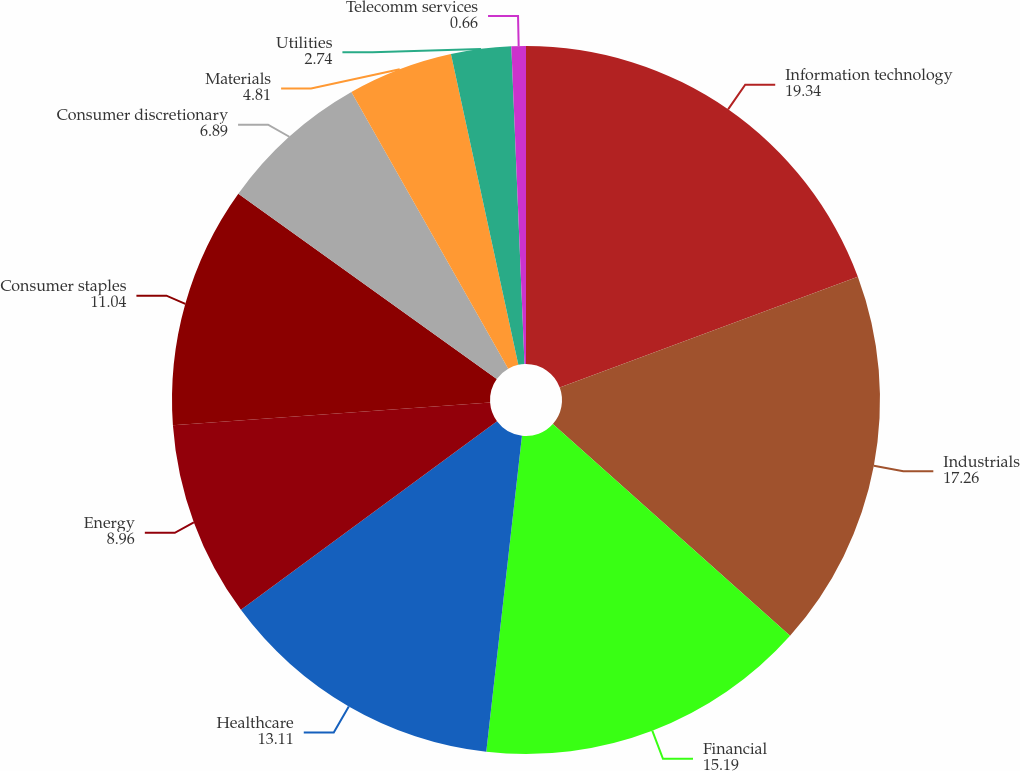Convert chart to OTSL. <chart><loc_0><loc_0><loc_500><loc_500><pie_chart><fcel>Information technology<fcel>Industrials<fcel>Financial<fcel>Healthcare<fcel>Energy<fcel>Consumer staples<fcel>Consumer discretionary<fcel>Materials<fcel>Utilities<fcel>Telecomm services<nl><fcel>19.34%<fcel>17.26%<fcel>15.19%<fcel>13.11%<fcel>8.96%<fcel>11.04%<fcel>6.89%<fcel>4.81%<fcel>2.74%<fcel>0.66%<nl></chart> 